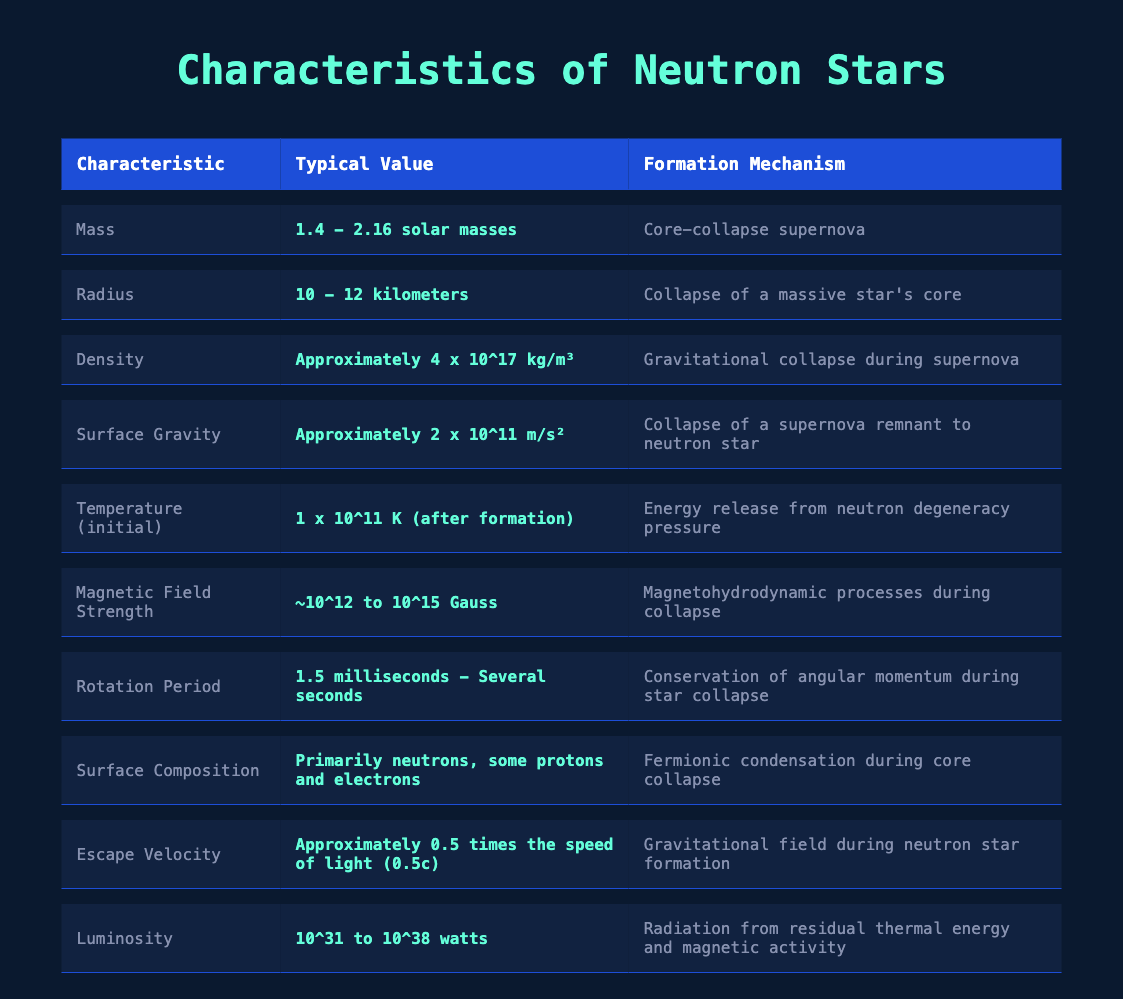What is the typical mass range of neutron stars? The table states that the typical mass of neutron stars ranges from **1.4 - 2.16 solar masses**.
Answer: 1.4 - 2.16 solar masses What is the typical radius of neutron stars? According to the table, the typical radius of neutron stars is **10 - 12 kilometers**.
Answer: 10 - 12 kilometers What is the density of neutron stars? The table indicates that the approximate density of neutron stars is **4 x 10^17 kg/m³**.
Answer: Approximately 4 x 10^17 kg/m³ Is the surface gravity of neutron stars greater than that of Earth? The surface gravity of neutron stars is approximately **2 x 10^11 m/s²**, which is significantly greater than Earth's surface gravity of **9.81 m/s²**. Thus, the statement is true.
Answer: Yes What is the initial temperature of a neutron star after formation? The table shows that the initial temperature after formation is **1 x 10^11 K**.
Answer: 1 x 10^11 K Calculate the average escape velocity of neutron stars if given 0.5c. The escape velocity is listed as approximately **0.5 times the speed of light (0.5c)**. To compute the average, considering the value is constant, the escape velocity is simply **0.5c**.
Answer: 0.5c What formation mechanism is associated with neutron stars having a high magnetic field strength? The table notes a formation mechanism for the high magnetic field strength (between **10^12 to 10^15 Gauss**) as **magnetohydrodynamic processes during collapse**.
Answer: Magnetohydrodynamic processes during collapse What is the typical range for the luminosity of neutron stars? The table states the typical luminosity ranges from **10^31 to 10^38 watts**.
Answer: 10^31 to 10^38 watts How do the rotation periods of neutron stars compare? From the table, the rotation periods range from **1.5 milliseconds to several seconds**, indicating a wide variance among neutron stars.
Answer: 1.5 milliseconds to several seconds What does the formation mechanism for surface composition indicate about the elements present in neutron stars? The formation mechanism explains that surface composition primarily consists of **neutrons**, with some **protons and electrons**, indicating that neutron stars are formed from nuclear reactions and degeneracy pressure.
Answer: Primarily neutrons, some protons and electrons 